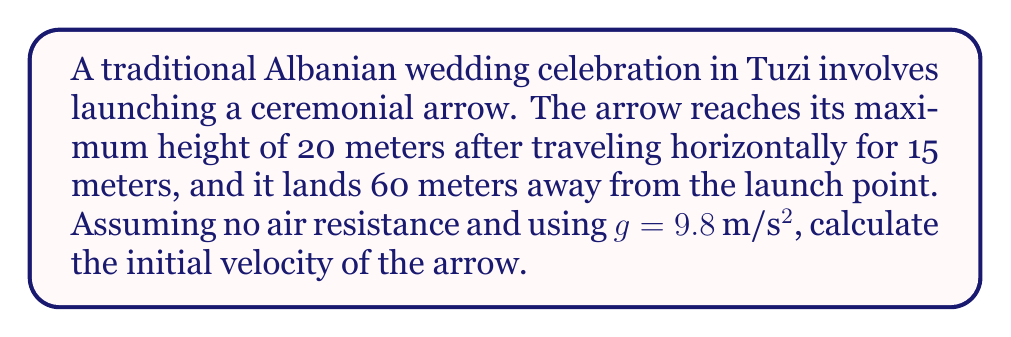Provide a solution to this math problem. Let's approach this step-by-step:

1) First, we need to break down the motion into horizontal and vertical components.

2) The horizontal motion is uniform:
   $x = v_0 \cos(\theta) \cdot t$
   where $v_0$ is the initial velocity, $\theta$ is the launch angle, and $t$ is the time.

3) The vertical motion is governed by:
   $y = v_0 \sin(\theta) \cdot t - \frac{1}{2}gt^2$

4) At the highest point, the vertical velocity is zero. We can use this to find the time to reach the maximum height:
   $t_{max} = \frac{v_0 \sin(\theta)}{g}$

5) We know that at the highest point, $x = 15$ m and $y = 20$ m. Using the horizontal motion equation:
   $15 = v_0 \cos(\theta) \cdot \frac{v_0 \sin(\theta)}{g}$

6) The total horizontal distance is 60 m, so the time of flight is twice the time to reach the highest point:
   $60 = v_0 \cos(\theta) \cdot 2\frac{v_0 \sin(\theta)}{g}$

7) Dividing these equations:
   $\frac{60}{15} = \frac{2v_0 \sin(\theta)}{v_0 \sin(\theta)} = 2$

   This confirms our assumption about the time of flight.

8) Now, using the vertical motion equation at the highest point:
   $20 = v_0 \sin(\theta) \cdot \frac{v_0 \sin(\theta)}{g} - \frac{1}{2}g(\frac{v_0 \sin(\theta)}{g})^2$

9) Simplifying:
   $20 = \frac{v_0^2 \sin^2(\theta)}{2g}$

10) Solving for $v_0$:
    $v_0 = \sqrt{\frac{40g}{\sin^2(\theta)}}$

11) From step 5:
    $\tan(\theta) = \frac{4g}{v_0^2} \cdot 15 = \frac{60g}{v_0^2}$

12) Substituting the expression for $v_0^2$ from step 10:
    $\tan(\theta) = \frac{60g}{\frac{40g}{\sin^2(\theta)}} = \frac{3}{2}\sin^2(\theta)$

13) This equation can be solved numerically to find $\theta ≈ 52.4°$

14) Finally, we can calculate $v_0$:
    $v_0 = \sqrt{\frac{40 \cdot 9.8}{(\sin 52.4°)^2}} ≈ 24.5$ m/s
Answer: $24.5$ m/s 